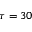<formula> <loc_0><loc_0><loc_500><loc_500>\tau = 3 0</formula> 